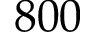<formula> <loc_0><loc_0><loc_500><loc_500>8 0 0</formula> 